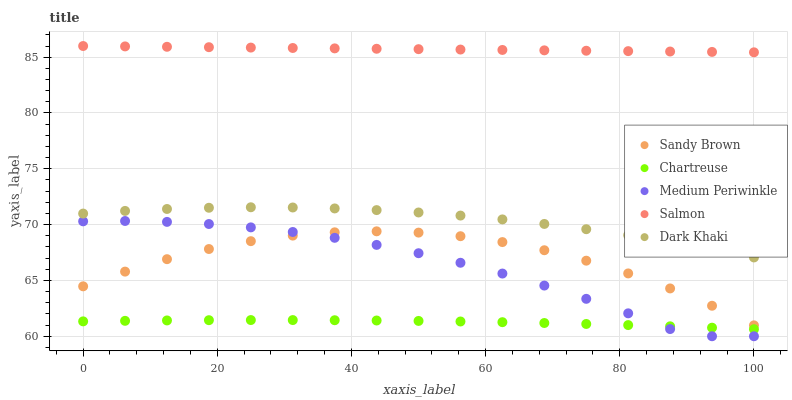Does Chartreuse have the minimum area under the curve?
Answer yes or no. Yes. Does Salmon have the maximum area under the curve?
Answer yes or no. Yes. Does Medium Periwinkle have the minimum area under the curve?
Answer yes or no. No. Does Medium Periwinkle have the maximum area under the curve?
Answer yes or no. No. Is Salmon the smoothest?
Answer yes or no. Yes. Is Sandy Brown the roughest?
Answer yes or no. Yes. Is Medium Periwinkle the smoothest?
Answer yes or no. No. Is Medium Periwinkle the roughest?
Answer yes or no. No. Does Medium Periwinkle have the lowest value?
Answer yes or no. Yes. Does Chartreuse have the lowest value?
Answer yes or no. No. Does Salmon have the highest value?
Answer yes or no. Yes. Does Medium Periwinkle have the highest value?
Answer yes or no. No. Is Chartreuse less than Dark Khaki?
Answer yes or no. Yes. Is Dark Khaki greater than Medium Periwinkle?
Answer yes or no. Yes. Does Sandy Brown intersect Medium Periwinkle?
Answer yes or no. Yes. Is Sandy Brown less than Medium Periwinkle?
Answer yes or no. No. Is Sandy Brown greater than Medium Periwinkle?
Answer yes or no. No. Does Chartreuse intersect Dark Khaki?
Answer yes or no. No. 